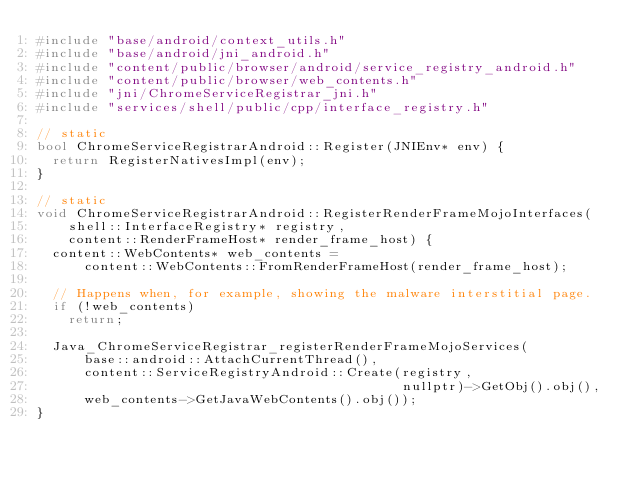Convert code to text. <code><loc_0><loc_0><loc_500><loc_500><_C++_>#include "base/android/context_utils.h"
#include "base/android/jni_android.h"
#include "content/public/browser/android/service_registry_android.h"
#include "content/public/browser/web_contents.h"
#include "jni/ChromeServiceRegistrar_jni.h"
#include "services/shell/public/cpp/interface_registry.h"

// static
bool ChromeServiceRegistrarAndroid::Register(JNIEnv* env) {
  return RegisterNativesImpl(env);
}

// static
void ChromeServiceRegistrarAndroid::RegisterRenderFrameMojoInterfaces(
    shell::InterfaceRegistry* registry,
    content::RenderFrameHost* render_frame_host) {
  content::WebContents* web_contents =
      content::WebContents::FromRenderFrameHost(render_frame_host);

  // Happens when, for example, showing the malware interstitial page.
  if (!web_contents)
    return;

  Java_ChromeServiceRegistrar_registerRenderFrameMojoServices(
      base::android::AttachCurrentThread(),
      content::ServiceRegistryAndroid::Create(registry,
                                              nullptr)->GetObj().obj(),
      web_contents->GetJavaWebContents().obj());
}
</code> 